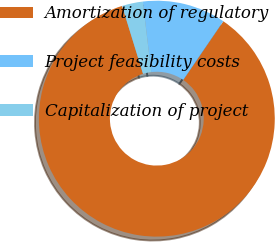Convert chart to OTSL. <chart><loc_0><loc_0><loc_500><loc_500><pie_chart><fcel>Amortization of regulatory<fcel>Project feasibility costs<fcel>Capitalization of project<nl><fcel>85.71%<fcel>11.43%<fcel>2.86%<nl></chart> 